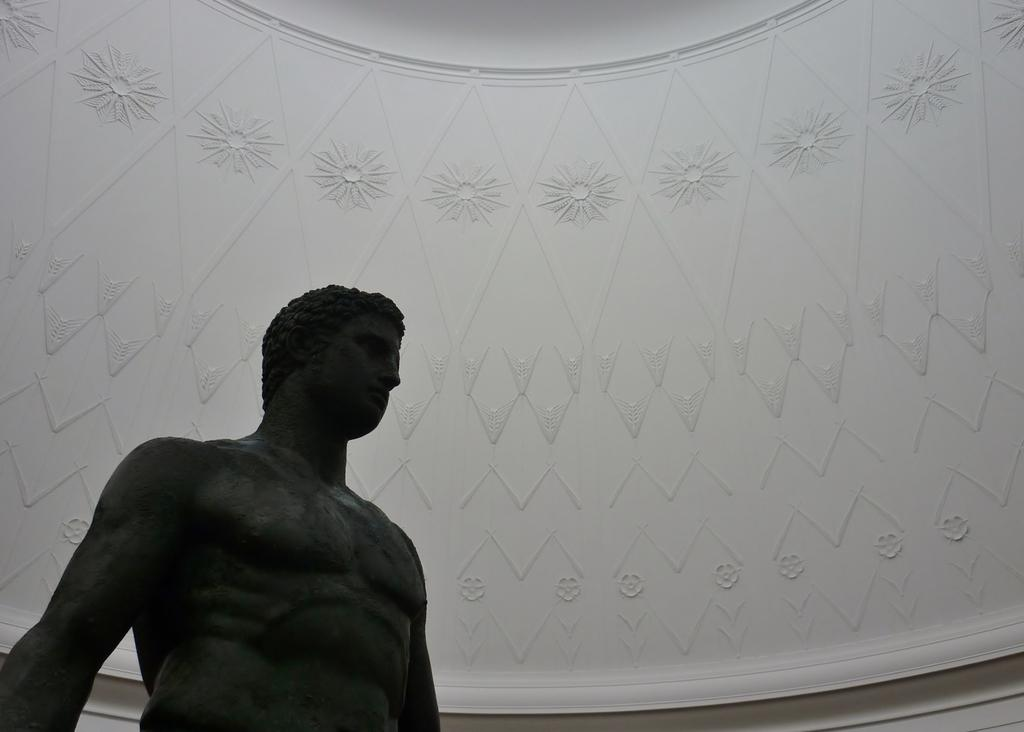What is the main subject in the foreground of the image? There is a statue of a person in the image. Where is the statue located in relation to the rest of the image? The statue is in the foreground of the image. What can be seen in the background of the image? There is a white color wall in the background of the image. Can you describe the wall in more detail? The wall has designs on it. What type of scarf is draped over the gate in the image? There is no gate or scarf present in the image; it features a statue of a person and a wall with designs in the background. 